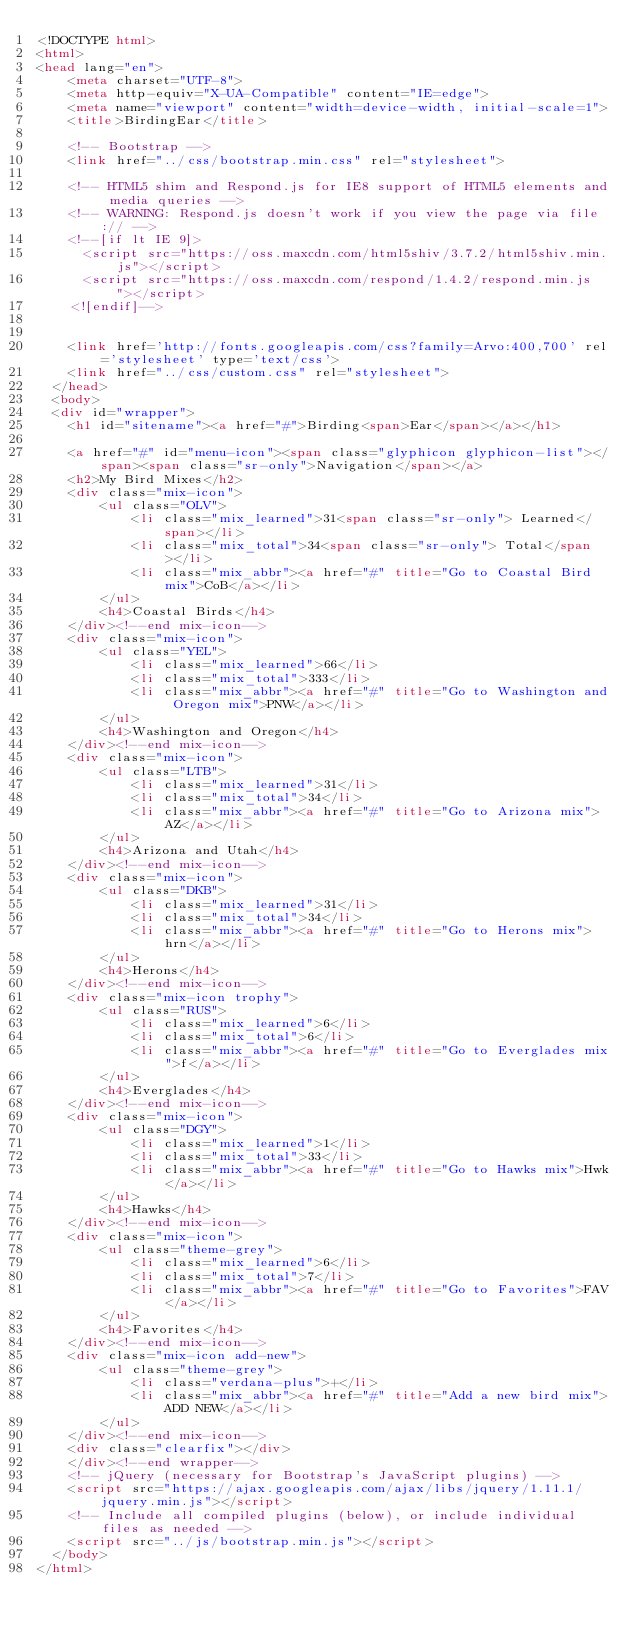Convert code to text. <code><loc_0><loc_0><loc_500><loc_500><_HTML_><!DOCTYPE html>
<html>
<head lang="en">
    <meta charset="UTF-8">
    <meta http-equiv="X-UA-Compatible" content="IE=edge">
    <meta name="viewport" content="width=device-width, initial-scale=1">
    <title>BirdingEar</title>

    <!-- Bootstrap -->
    <link href="../css/bootstrap.min.css" rel="stylesheet">

    <!-- HTML5 shim and Respond.js for IE8 support of HTML5 elements and media queries -->
    <!-- WARNING: Respond.js doesn't work if you view the page via file:// -->
    <!--[if lt IE 9]>
      <script src="https://oss.maxcdn.com/html5shiv/3.7.2/html5shiv.min.js"></script>
      <script src="https://oss.maxcdn.com/respond/1.4.2/respond.min.js"></script>
    <![endif]-->


    <link href='http://fonts.googleapis.com/css?family=Arvo:400,700' rel='stylesheet' type='text/css'>
    <link href="../css/custom.css" rel="stylesheet">
  </head>
  <body>
  <div id="wrapper">
    <h1 id="sitename"><a href="#">Birding<span>Ear</span></a></h1>

    <a href="#" id="menu-icon"><span class="glyphicon glyphicon-list"></span><span class="sr-only">Navigation</span></a>
    <h2>My Bird Mixes</h2>
    <div class="mix-icon">
        <ul class="OLV">
            <li class="mix_learned">31<span class="sr-only"> Learned</span></li>
            <li class="mix_total">34<span class="sr-only"> Total</span></li>
            <li class="mix_abbr"><a href="#" title="Go to Coastal Bird mix">CoB</a></li>
        </ul>
        <h4>Coastal Birds</h4>
    </div><!--end mix-icon-->
    <div class="mix-icon">
        <ul class="YEL">
            <li class="mix_learned">66</li>
            <li class="mix_total">333</li>
            <li class="mix_abbr"><a href="#" title="Go to Washington and Oregon mix">PNW</a></li>
        </ul>
        <h4>Washington and Oregon</h4>
    </div><!--end mix-icon-->
    <div class="mix-icon">
        <ul class="LTB">
            <li class="mix_learned">31</li>
            <li class="mix_total">34</li>
            <li class="mix_abbr"><a href="#" title="Go to Arizona mix">AZ</a></li>
        </ul>
        <h4>Arizona and Utah</h4>
    </div><!--end mix-icon-->
    <div class="mix-icon">
        <ul class="DKB">
            <li class="mix_learned">31</li>
            <li class="mix_total">34</li>
            <li class="mix_abbr"><a href="#" title="Go to Herons mix">hrn</a></li>
        </ul>
        <h4>Herons</h4>
    </div><!--end mix-icon-->
    <div class="mix-icon trophy">
        <ul class="RUS">
            <li class="mix_learned">6</li>
            <li class="mix_total">6</li>
            <li class="mix_abbr"><a href="#" title="Go to Everglades mix">f</a></li>
        </ul>
        <h4>Everglades</h4>
    </div><!--end mix-icon-->
    <div class="mix-icon">
        <ul class="DGY">
            <li class="mix_learned">1</li>
            <li class="mix_total">33</li>
            <li class="mix_abbr"><a href="#" title="Go to Hawks mix">Hwk</a></li>
        </ul>
        <h4>Hawks</h4>
    </div><!--end mix-icon-->
    <div class="mix-icon">
        <ul class="theme-grey">
            <li class="mix_learned">6</li>
            <li class="mix_total">7</li>
            <li class="mix_abbr"><a href="#" title="Go to Favorites">FAV</a></li>
        </ul>
        <h4>Favorites</h4>
    </div><!--end mix-icon-->
    <div class="mix-icon add-new">
        <ul class="theme-grey">
            <li class="verdana-plus">+</li>
            <li class="mix_abbr"><a href="#" title="Add a new bird mix">ADD NEW</a></li>
        </ul>
    </div><!--end mix-icon-->
    <div class="clearfix"></div>
    </div><!--end wrapper-->
    <!-- jQuery (necessary for Bootstrap's JavaScript plugins) -->
    <script src="https://ajax.googleapis.com/ajax/libs/jquery/1.11.1/jquery.min.js"></script>
    <!-- Include all compiled plugins (below), or include individual files as needed -->
    <script src="../js/bootstrap.min.js"></script>
  </body>
</html></code> 